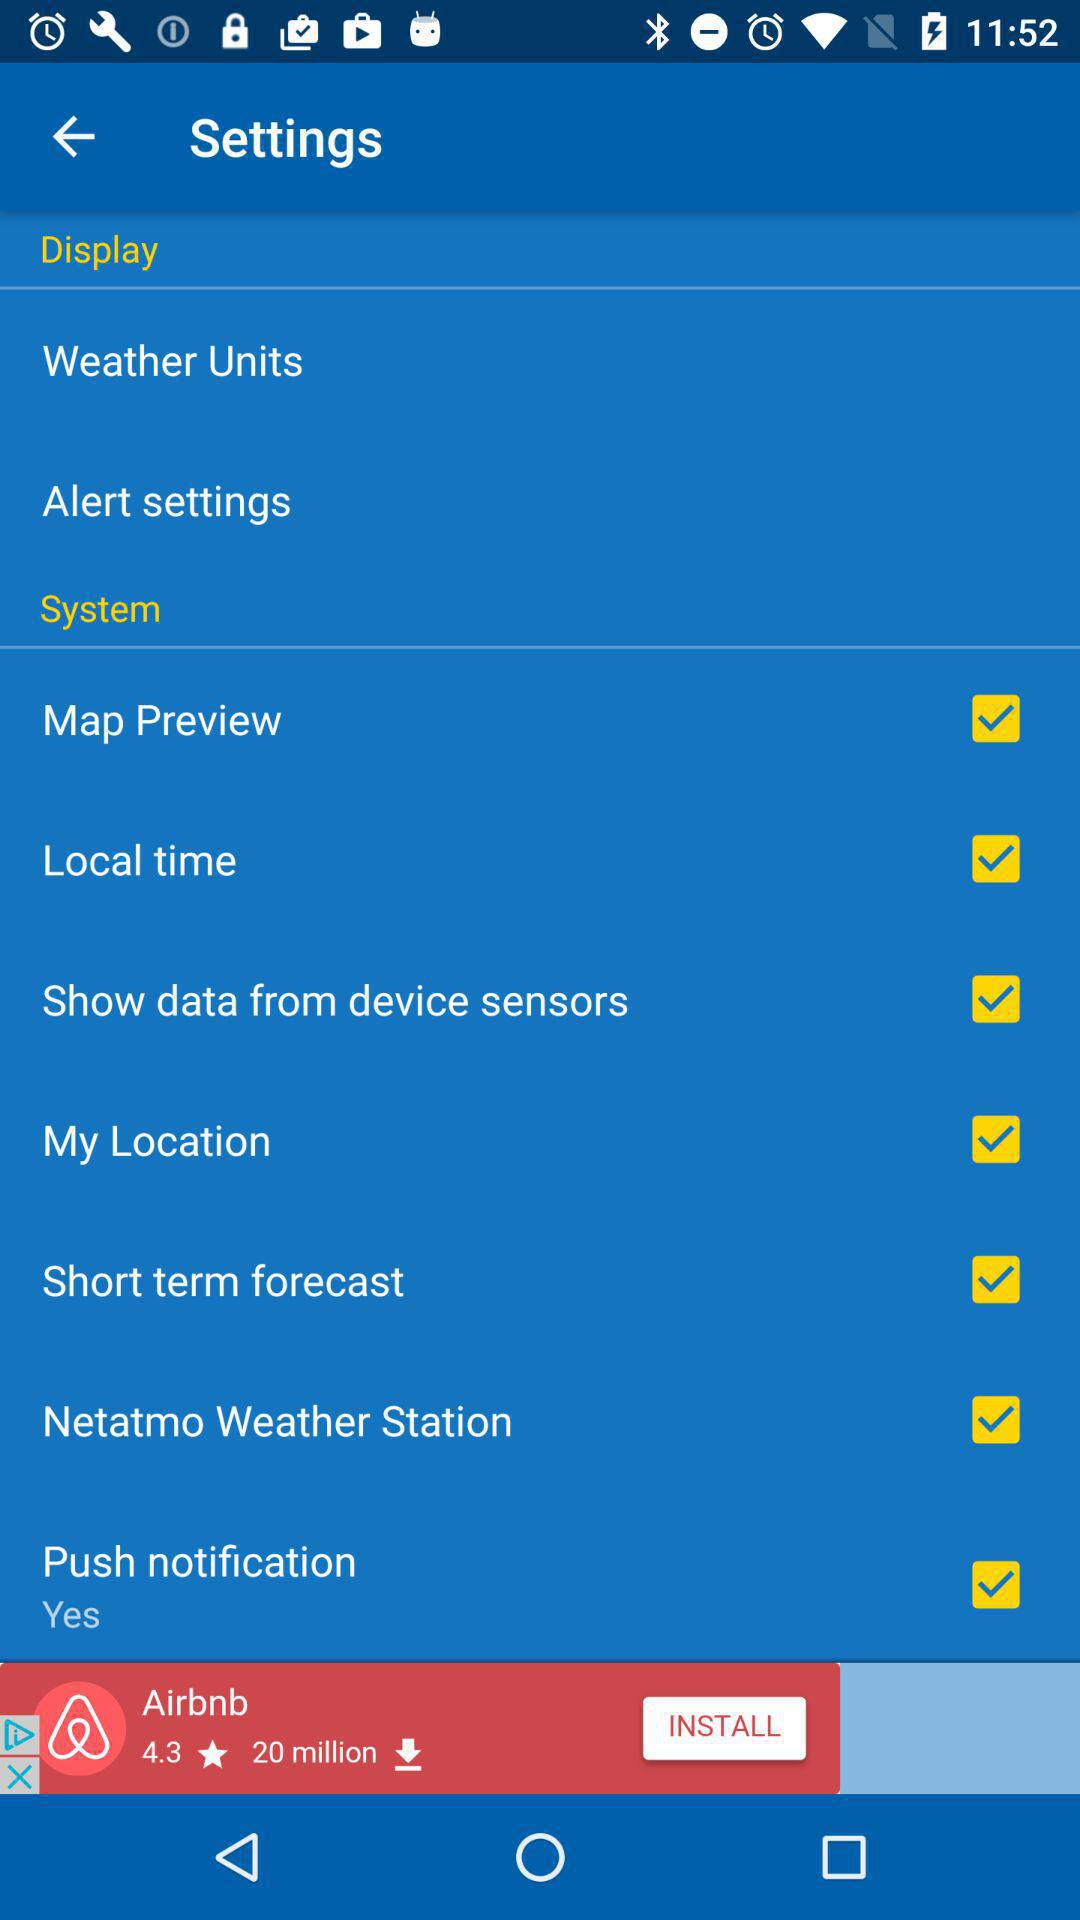Is "Push notification" checked or unchecked? "Push notification" is checked. 